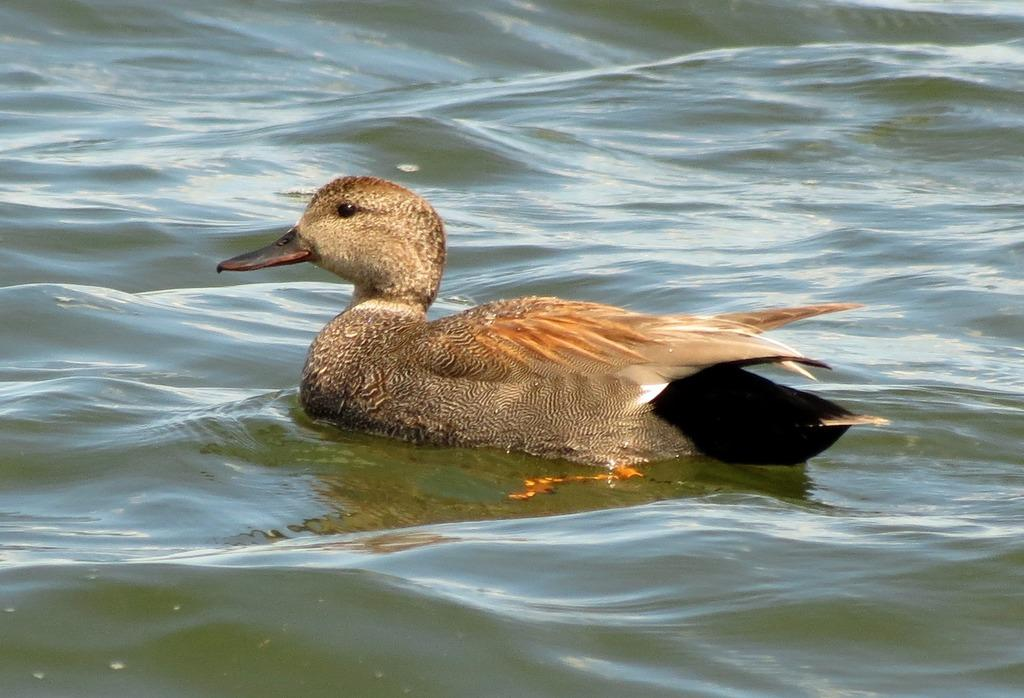What is the main subject in the center of the image? There is a bird in the center of the image. What can be seen around the bird in the image? There is water around the area of the image. What type of jam is being spread on the bird in the image? There is no jam present in the image, and the bird is not being spread with any substance. 